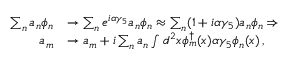Convert formula to latex. <formula><loc_0><loc_0><loc_500><loc_500>\begin{array} { r l } { \sum _ { n } a _ { n } \phi _ { n } } & { \rightarrow \sum _ { n } e ^ { i \alpha \gamma _ { 5 } } a _ { n } \phi _ { n } \approx \sum _ { n } ( 1 + i \alpha \gamma _ { 5 } ) a _ { n } \phi _ { n } \Rightarrow } \\ { a _ { m } } & { \rightarrow a _ { m } + i \sum _ { n } a _ { n } \int d ^ { 2 } x \phi _ { m } ^ { \dagger } ( x ) \alpha \gamma _ { 5 } \phi _ { n } ( x ) \, , } \end{array}</formula> 